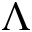<formula> <loc_0><loc_0><loc_500><loc_500>\Lambda</formula> 